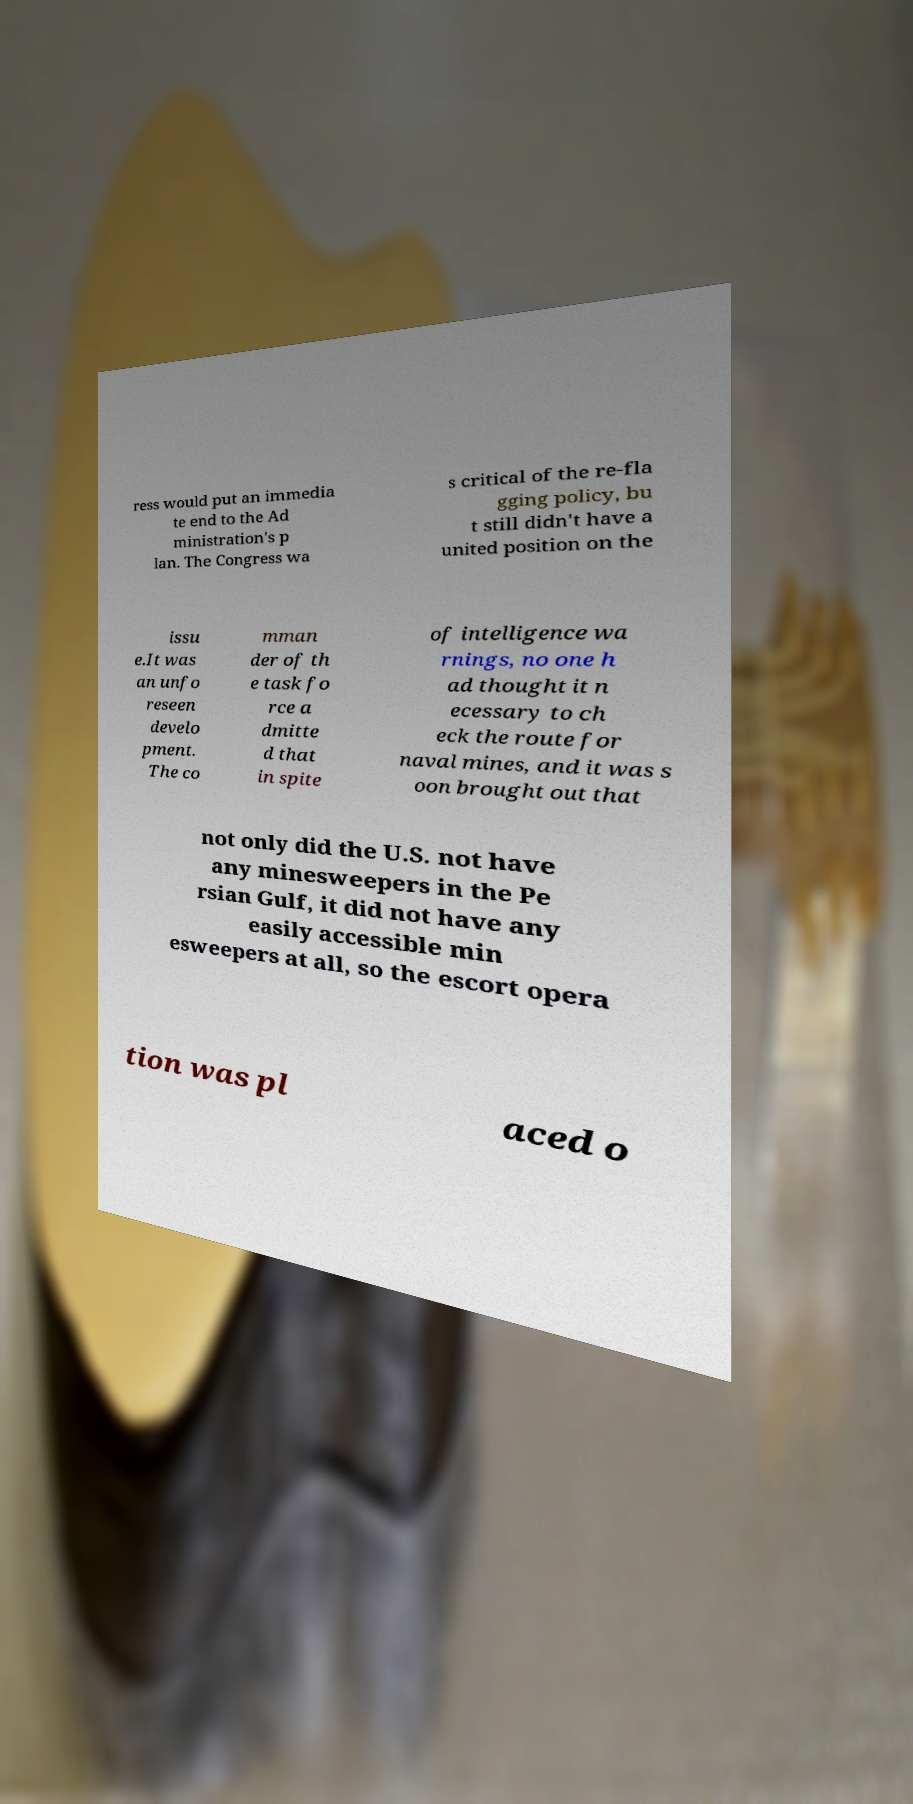There's text embedded in this image that I need extracted. Can you transcribe it verbatim? ress would put an immedia te end to the Ad ministration's p lan. The Congress wa s critical of the re-fla gging policy, bu t still didn't have a united position on the issu e.It was an unfo reseen develo pment. The co mman der of th e task fo rce a dmitte d that in spite of intelligence wa rnings, no one h ad thought it n ecessary to ch eck the route for naval mines, and it was s oon brought out that not only did the U.S. not have any minesweepers in the Pe rsian Gulf, it did not have any easily accessible min esweepers at all, so the escort opera tion was pl aced o 